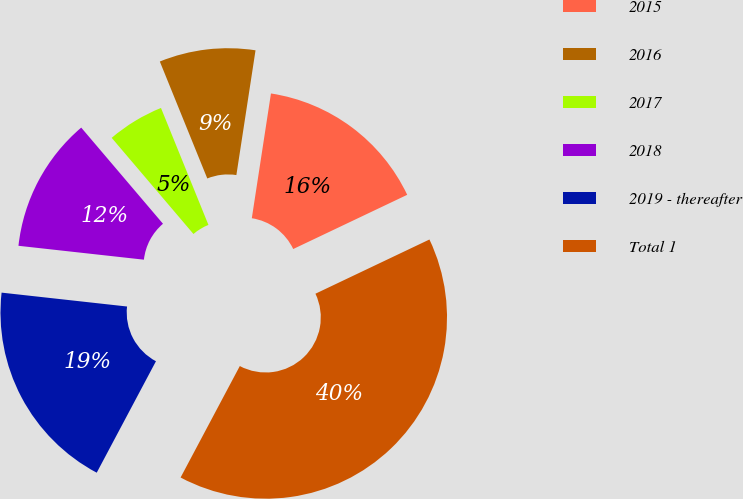Convert chart to OTSL. <chart><loc_0><loc_0><loc_500><loc_500><pie_chart><fcel>2015<fcel>2016<fcel>2017<fcel>2018<fcel>2019 - thereafter<fcel>Total 1<nl><fcel>15.51%<fcel>8.56%<fcel>5.08%<fcel>12.03%<fcel>18.98%<fcel>39.84%<nl></chart> 